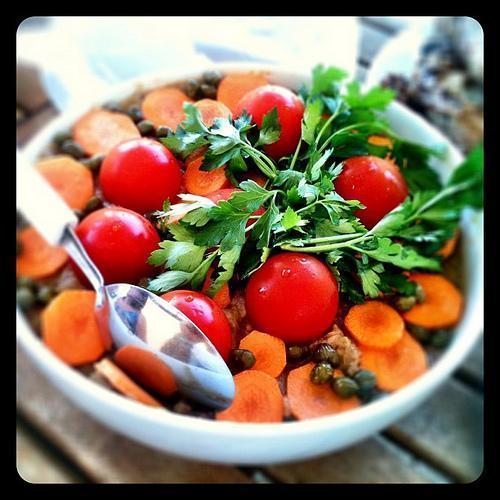How many tomatoes?
Give a very brief answer. 6. 